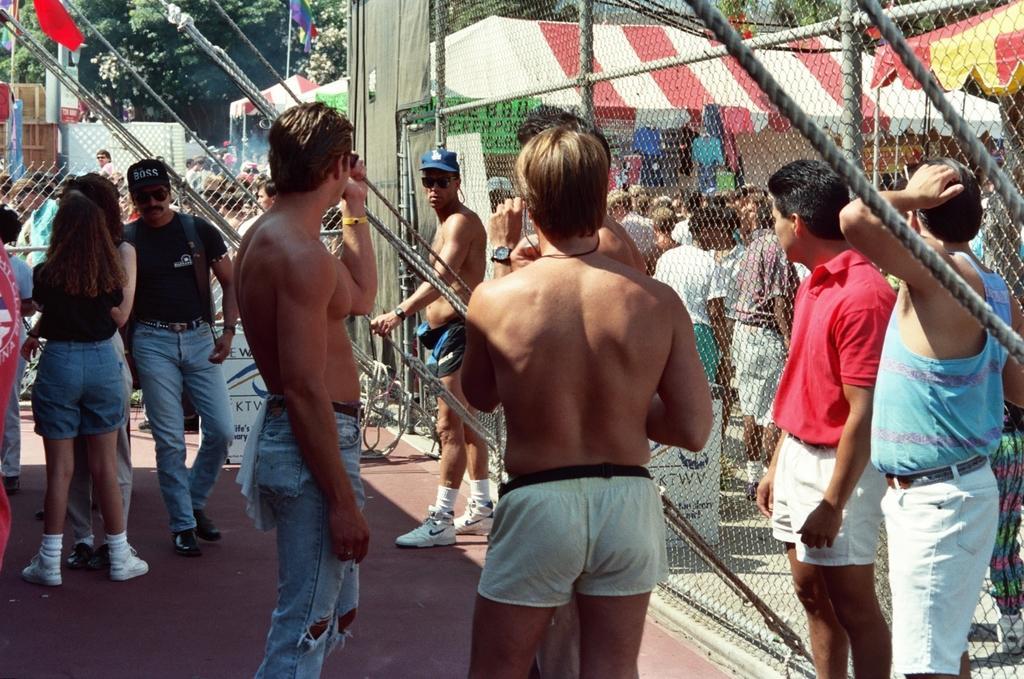Please provide a concise description of this image. In the image e can see there are many people standing, they are wearing clothes, shorts, shoes and some of them are wearing cap and goggles. This is a footpath, fence, flag, trees and tent. This is a poster, pole and rope. 